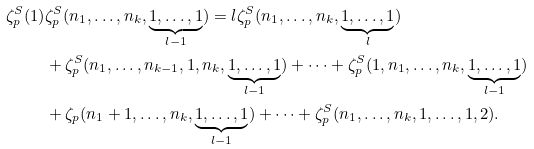Convert formula to latex. <formula><loc_0><loc_0><loc_500><loc_500>\zeta _ { p } ^ { S } ( 1 ) & \zeta _ { p } ^ { S } ( n _ { 1 } , \dots , n _ { k } , \underbrace { 1 , \dots , 1 } _ { l - 1 } ) = l \zeta _ { p } ^ { S } ( n _ { 1 } , \dots , n _ { k } , \underbrace { 1 , \dots , 1 } _ { l } ) \\ & + \zeta _ { p } ^ { S } ( n _ { 1 } , \dots , n _ { k - 1 } , 1 , n _ { k } , \underbrace { 1 , \dots , 1 } _ { l - 1 } ) + \dots + \zeta _ { p } ^ { S } ( 1 , n _ { 1 } , \dots , n _ { k } , \underbrace { 1 , \dots , 1 } _ { l - 1 } ) \\ & + \zeta _ { p } ( n _ { 1 } + 1 , \dots , n _ { k } , \underbrace { 1 , \dots , 1 } _ { l - 1 } ) + \dots + \zeta _ { p } ^ { S } ( n _ { 1 } , \dots , n _ { k } , 1 , \dots , 1 , 2 ) .</formula> 